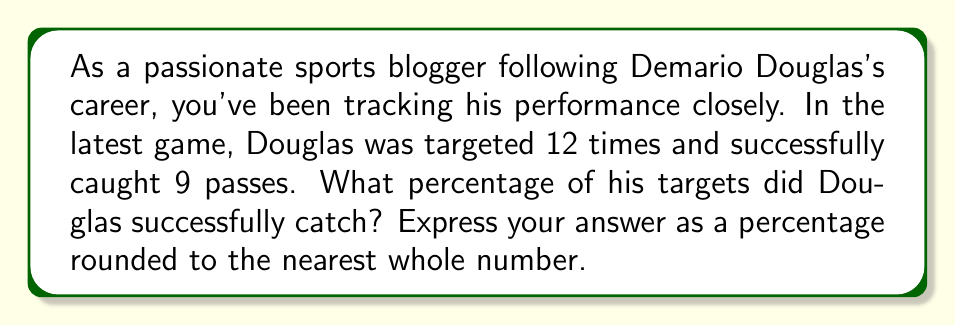Solve this math problem. To solve this problem, we need to follow these steps:

1. Identify the given information:
   - Total targets: 12
   - Successful catches: 9

2. Calculate the percentage of successful catches:
   
   The formula for calculating a percentage is:
   
   $$ \text{Percentage} = \frac{\text{Part}}{\text{Whole}} \times 100\% $$

   In this case:
   - Part = Successful catches = 9
   - Whole = Total targets = 12

   Let's plug these values into the formula:

   $$ \text{Percentage} = \frac{9}{12} \times 100\% $$

3. Perform the calculation:
   
   $$ \text{Percentage} = 0.75 \times 100\% = 75\% $$

4. Round to the nearest whole number:
   
   75% is already a whole number, so no rounding is necessary.

Therefore, Demario Douglas successfully caught 75% of his targets in the game.
Answer: 75% 